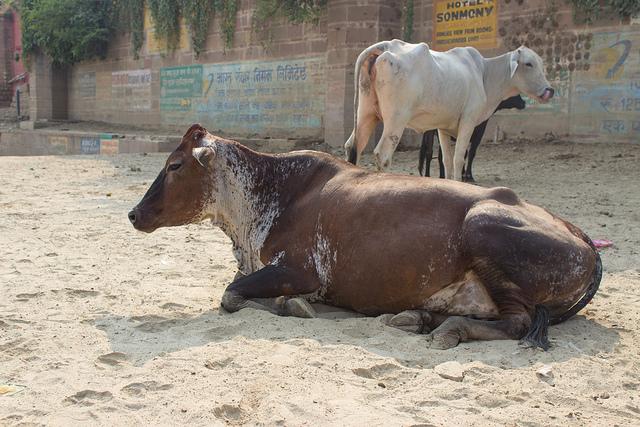Was this photo likely to have been taken in the United States?
Concise answer only. No. Is the animal trying to take a nap?
Concise answer only. Yes. How many cows are there?
Write a very short answer. 2. Was this taken in the desert?
Keep it brief. No. 